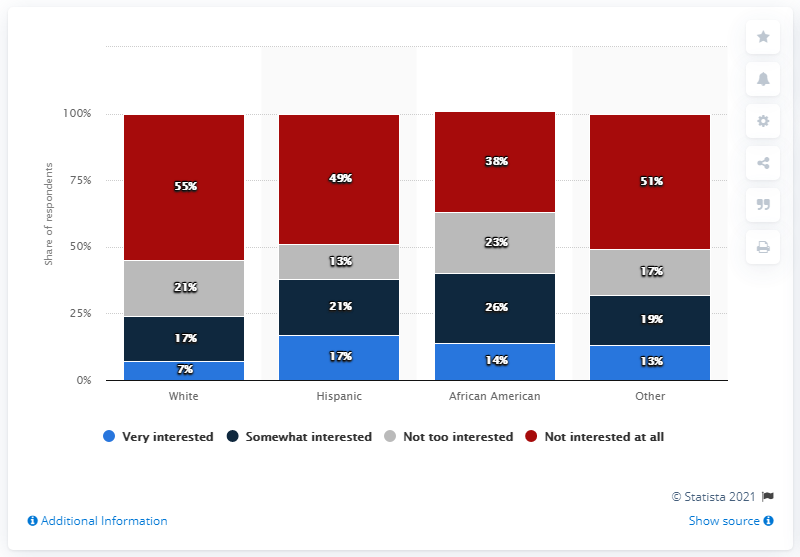What percentage of African Americans are shown to be not too interested in soccer? According to the bar graph, 26% of African American respondents are not too interested in soccer. 